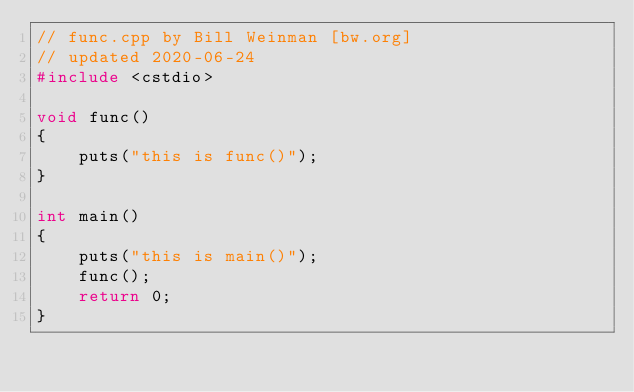<code> <loc_0><loc_0><loc_500><loc_500><_C++_>// func.cpp by Bill Weinman [bw.org]
// updated 2020-06-24
#include <cstdio>

void func()
{
    puts("this is func()");
}

int main()
{
    puts("this is main()");
    func();
    return 0;
}

</code> 